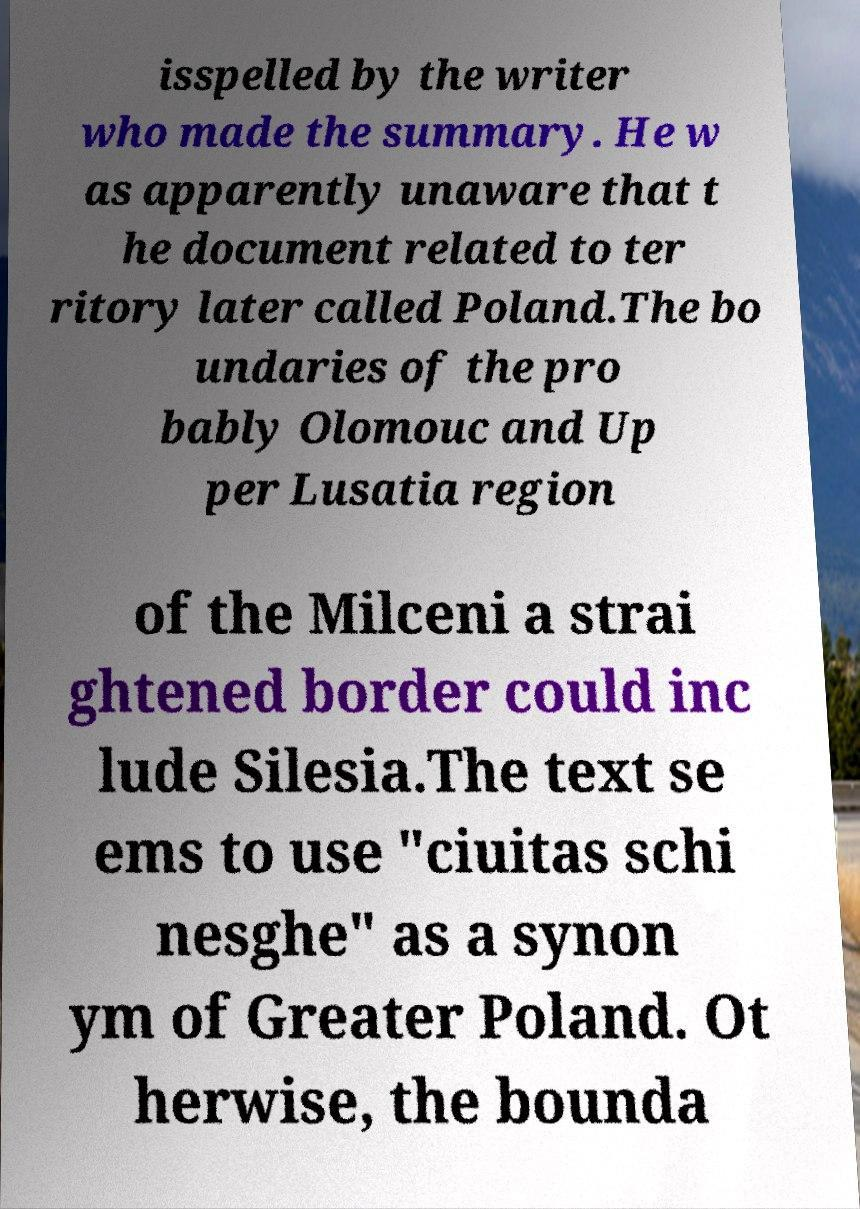Can you accurately transcribe the text from the provided image for me? isspelled by the writer who made the summary. He w as apparently unaware that t he document related to ter ritory later called Poland.The bo undaries of the pro bably Olomouc and Up per Lusatia region of the Milceni a strai ghtened border could inc lude Silesia.The text se ems to use "ciuitas schi nesghe" as a synon ym of Greater Poland. Ot herwise, the bounda 